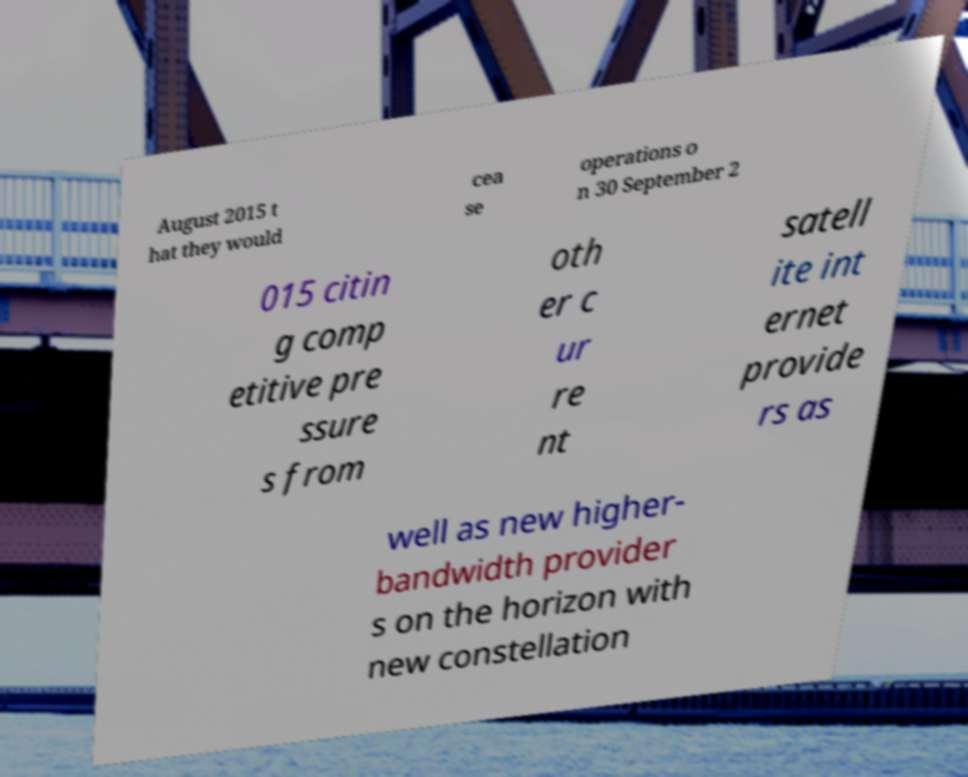Could you assist in decoding the text presented in this image and type it out clearly? August 2015 t hat they would cea se operations o n 30 September 2 015 citin g comp etitive pre ssure s from oth er c ur re nt satell ite int ernet provide rs as well as new higher- bandwidth provider s on the horizon with new constellation 